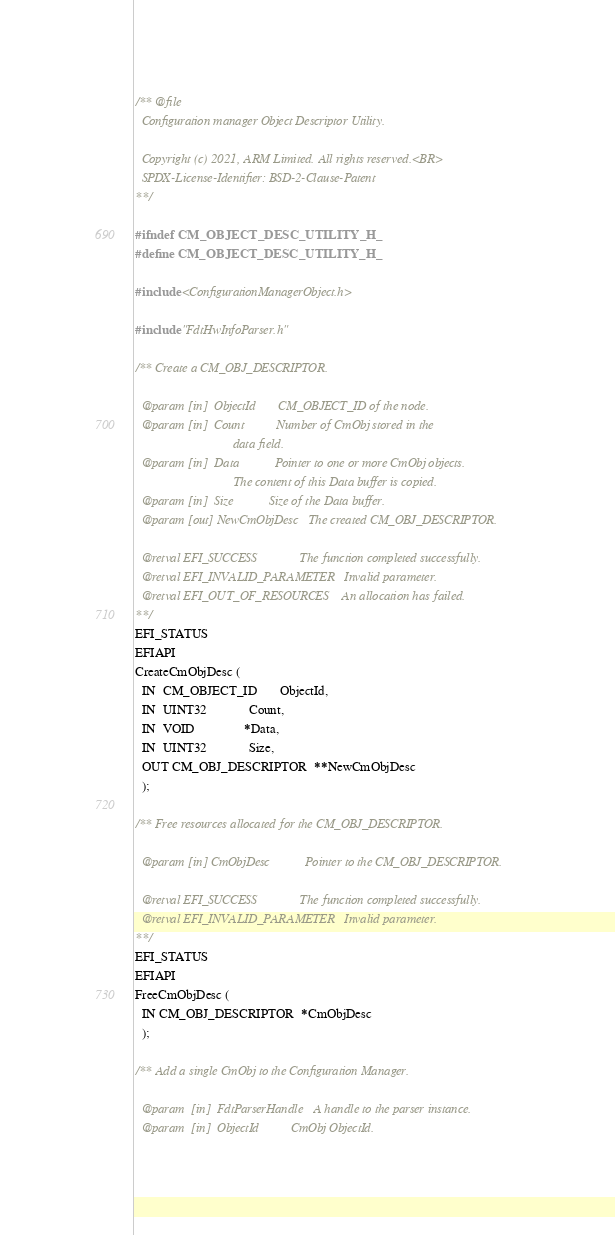<code> <loc_0><loc_0><loc_500><loc_500><_C_>/** @file
  Configuration manager Object Descriptor Utility.

  Copyright (c) 2021, ARM Limited. All rights reserved.<BR>
  SPDX-License-Identifier: BSD-2-Clause-Patent
**/

#ifndef CM_OBJECT_DESC_UTILITY_H_
#define CM_OBJECT_DESC_UTILITY_H_

#include <ConfigurationManagerObject.h>

#include "FdtHwInfoParser.h"

/** Create a CM_OBJ_DESCRIPTOR.

  @param [in]  ObjectId       CM_OBJECT_ID of the node.
  @param [in]  Count          Number of CmObj stored in the
                              data field.
  @param [in]  Data           Pointer to one or more CmObj objects.
                              The content of this Data buffer is copied.
  @param [in]  Size           Size of the Data buffer.
  @param [out] NewCmObjDesc   The created CM_OBJ_DESCRIPTOR.

  @retval EFI_SUCCESS             The function completed successfully.
  @retval EFI_INVALID_PARAMETER   Invalid parameter.
  @retval EFI_OUT_OF_RESOURCES    An allocation has failed.
**/
EFI_STATUS
EFIAPI
CreateCmObjDesc (
  IN  CM_OBJECT_ID       ObjectId,
  IN  UINT32             Count,
  IN  VOID               *Data,
  IN  UINT32             Size,
  OUT CM_OBJ_DESCRIPTOR  **NewCmObjDesc
  );

/** Free resources allocated for the CM_OBJ_DESCRIPTOR.

  @param [in] CmObjDesc           Pointer to the CM_OBJ_DESCRIPTOR.

  @retval EFI_SUCCESS             The function completed successfully.
  @retval EFI_INVALID_PARAMETER   Invalid parameter.
**/
EFI_STATUS
EFIAPI
FreeCmObjDesc (
  IN CM_OBJ_DESCRIPTOR  *CmObjDesc
  );

/** Add a single CmObj to the Configuration Manager.

  @param  [in]  FdtParserHandle   A handle to the parser instance.
  @param  [in]  ObjectId          CmObj ObjectId.</code> 